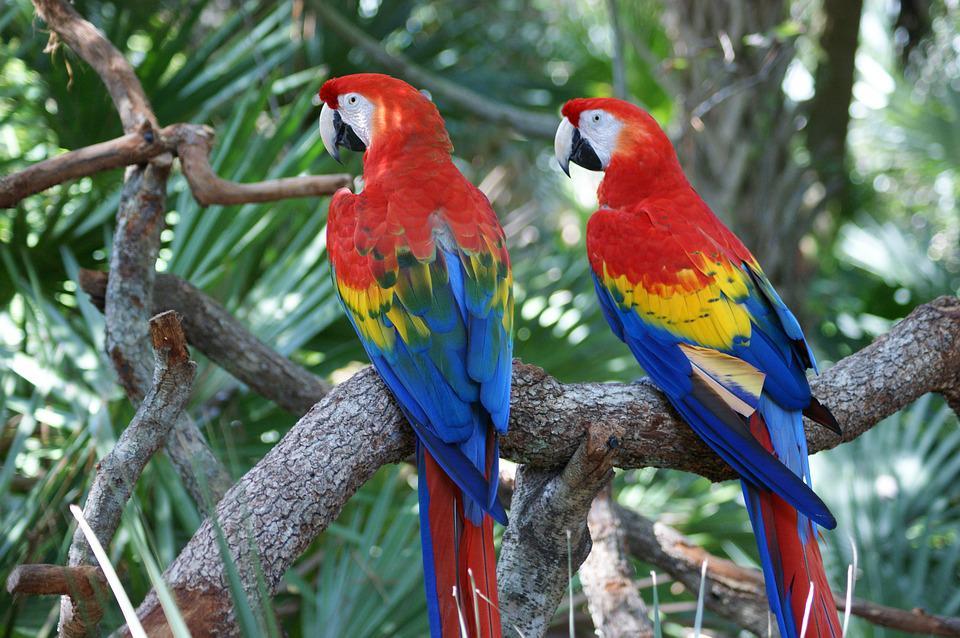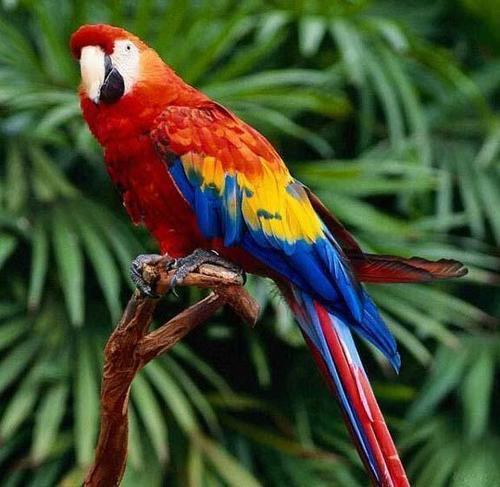The first image is the image on the left, the second image is the image on the right. Evaluate the accuracy of this statement regarding the images: "One of the images contains exactly one parrot.". Is it true? Answer yes or no. Yes. 